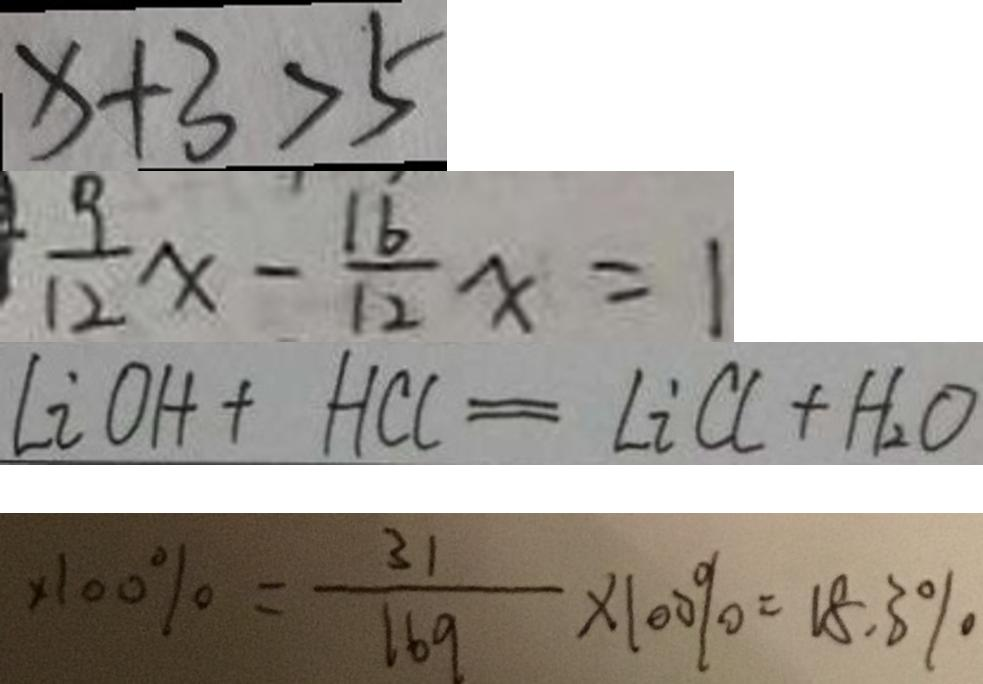Convert formula to latex. <formula><loc_0><loc_0><loc_500><loc_500>x + 3 > 5 
 \frac { 9 } { 1 2 } x - \frac { 1 6 } { 1 2 } x = 1 
 l i o H + H C l = L i C l + H _ { 2 } O 
 \times 1 0 0 \% = \frac { 3 1 } { 1 6 9 } \times 1 0 0 \% = 1 8 . 3 \%</formula> 